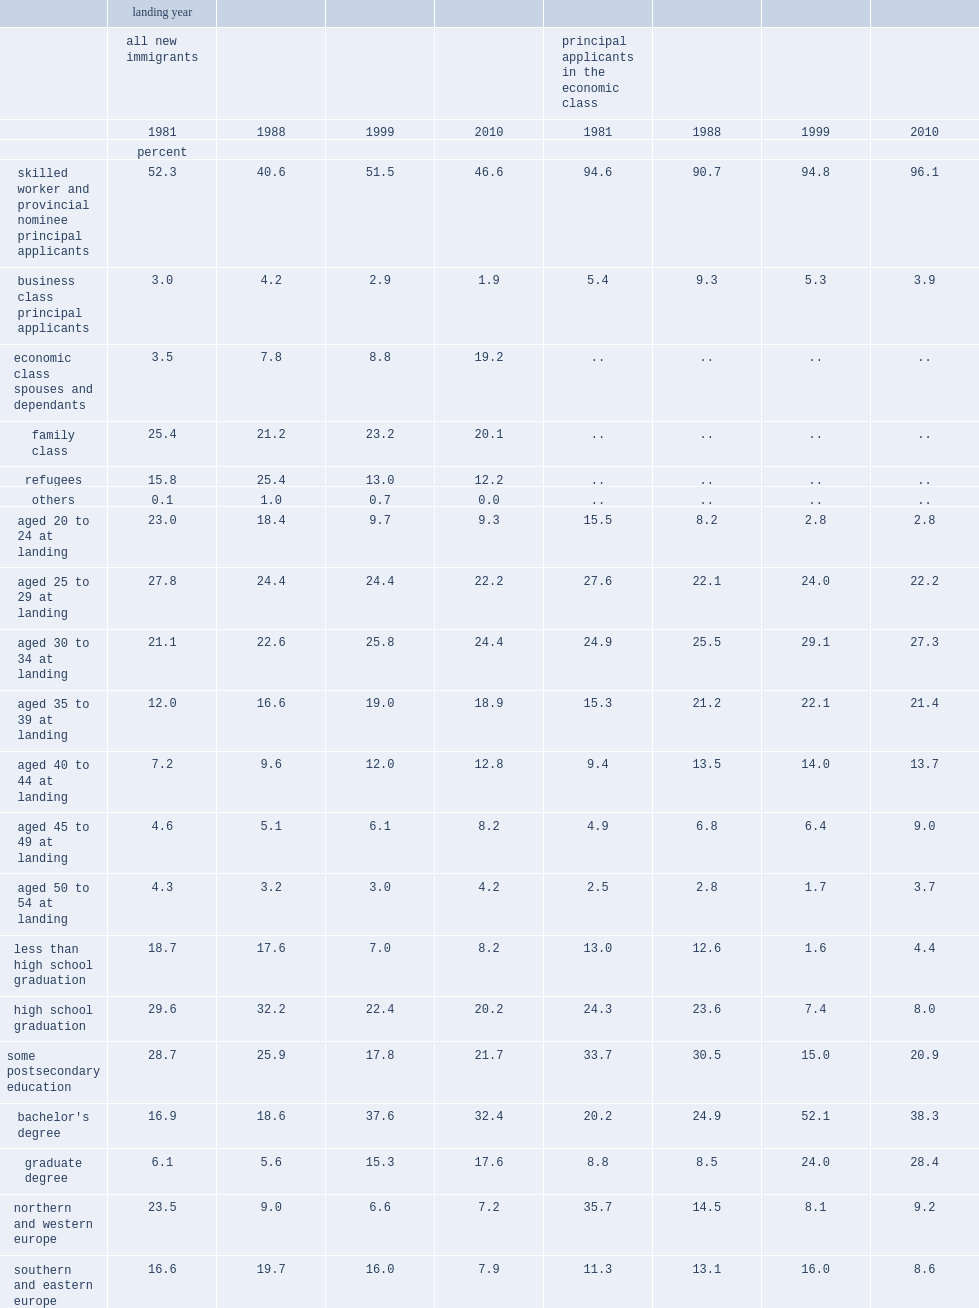Among new immigrant men in the study sample, what was the proportion of those with a university degree for the 1988 cohort? 24.2. Among new immigrant men in the study sample, what was the proportion of those with a university degree for the 1999 cohort? 52.9. Among men, what was the share of new immigrants in the economic class (including sw pas, business class pas, and economic class spouses and dependants) for the 1988 cohort? 52.6. Among men, what was the share of new immigrants in the economic class (including sw pas, business class pas, and economic class spouses and dependants) for the 1999 cohort? 63.2. What was the share of immigrant men who were economic classspouses in 1999? 8.8. What was the share of immigrant men who were economic classspouses in 2010? 19.2. Among principal applicants in the economic class, what was the share of immigrants with a high-paying job (paying more than $50,000) in 1999? 3.6. Among principal applicants in the economic class, what was the share of immigrants with a high-paying job (paying more than $50,000) in 2010? 13.0. 